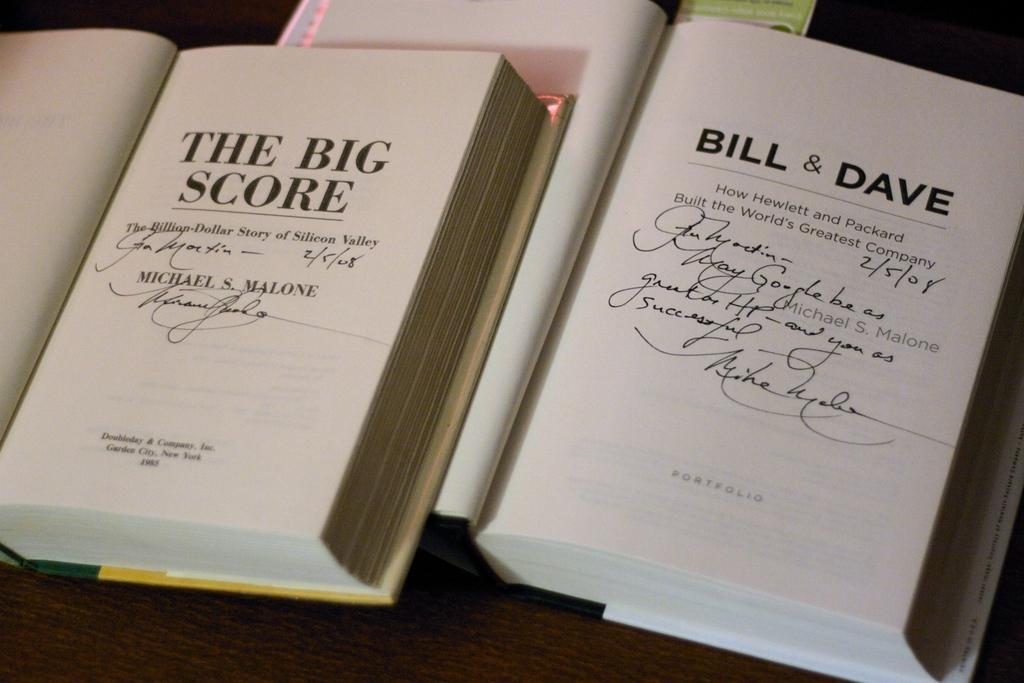<image>
Offer a succinct explanation of the picture presented. Novels with the titles of, "The Big Score" and "Bill & Dave" both have autographs signed on their first pages. 